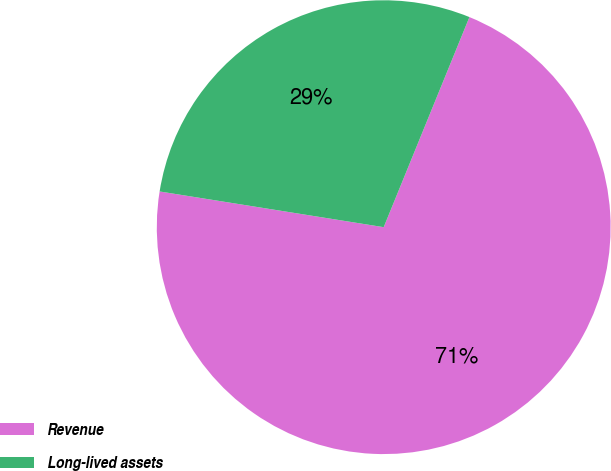Convert chart to OTSL. <chart><loc_0><loc_0><loc_500><loc_500><pie_chart><fcel>Revenue<fcel>Long-lived assets<nl><fcel>71.35%<fcel>28.65%<nl></chart> 